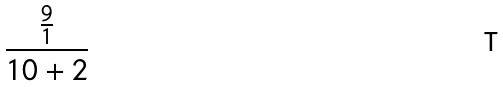<formula> <loc_0><loc_0><loc_500><loc_500>\frac { \frac { 9 } { 1 } } { 1 0 + 2 }</formula> 